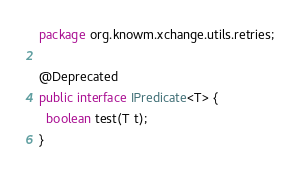Convert code to text. <code><loc_0><loc_0><loc_500><loc_500><_Java_>package org.knowm.xchange.utils.retries;

@Deprecated
public interface IPredicate<T> {
  boolean test(T t);
}
</code> 